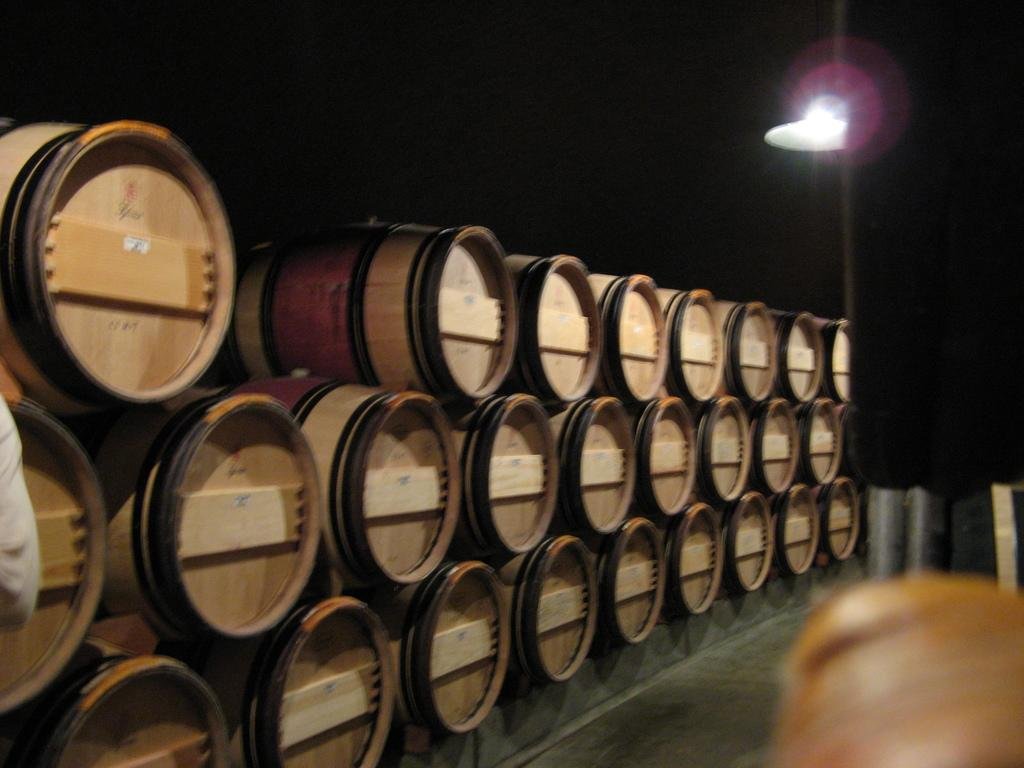What musical instruments are present in the image? There are drums in the image. How are the drums arranged? The drums are arranged in an order. What additional object can be seen near the drums? There is a light beside the drums. What type of vegetable is being used as a chin rest for the drums in the image? There is no vegetable present in the image, nor is there any indication that a chin rest is being used for the drums. 